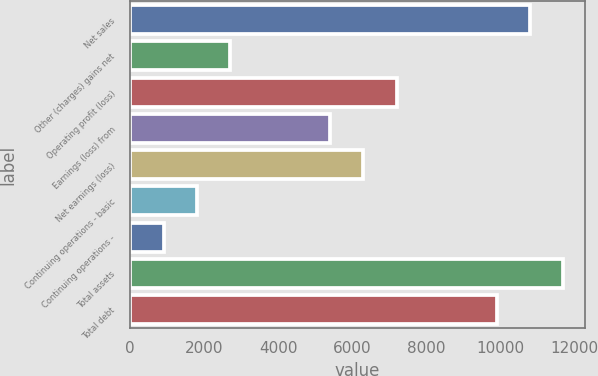Convert chart. <chart><loc_0><loc_0><loc_500><loc_500><bar_chart><fcel>Net sales<fcel>Other (charges) gains net<fcel>Operating profit (loss)<fcel>Earnings (loss) from<fcel>Net earnings (loss)<fcel>Continuing operations - basic<fcel>Continuing operations -<fcel>Total assets<fcel>Total debt<nl><fcel>10792.7<fcel>2698.58<fcel>7195.33<fcel>5396.63<fcel>6295.98<fcel>1799.23<fcel>899.88<fcel>11692.1<fcel>9893.38<nl></chart> 